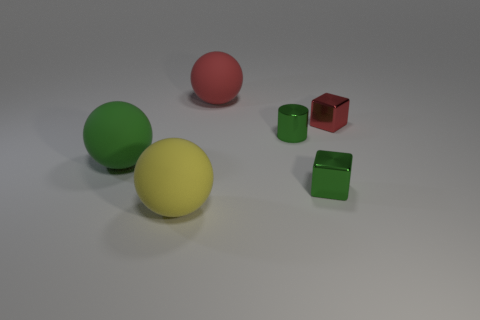The red thing that is the same size as the green cylinder is what shape?
Give a very brief answer. Cube. How many things are either rubber spheres that are to the right of the large yellow object or red shiny objects?
Your answer should be very brief. 2. There is a rubber sphere in front of the green rubber thing; how big is it?
Give a very brief answer. Large. Is there a green rubber ball of the same size as the metal cylinder?
Make the answer very short. No. There is a rubber object on the left side of the yellow thing; does it have the same size as the red metallic object?
Ensure brevity in your answer.  No. What is the size of the red metal cube?
Provide a succinct answer. Small. What is the color of the ball that is in front of the small metallic object in front of the ball that is left of the big yellow matte thing?
Provide a short and direct response. Yellow. Does the matte object behind the large green matte object have the same color as the cylinder?
Offer a very short reply. No. How many objects are both on the right side of the yellow matte object and in front of the big green object?
Provide a succinct answer. 1. There is another object that is the same shape as the small red thing; what size is it?
Your answer should be very brief. Small. 